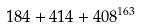<formula> <loc_0><loc_0><loc_500><loc_500>1 8 4 + 4 1 4 + 4 0 8 ^ { 1 6 3 }</formula> 